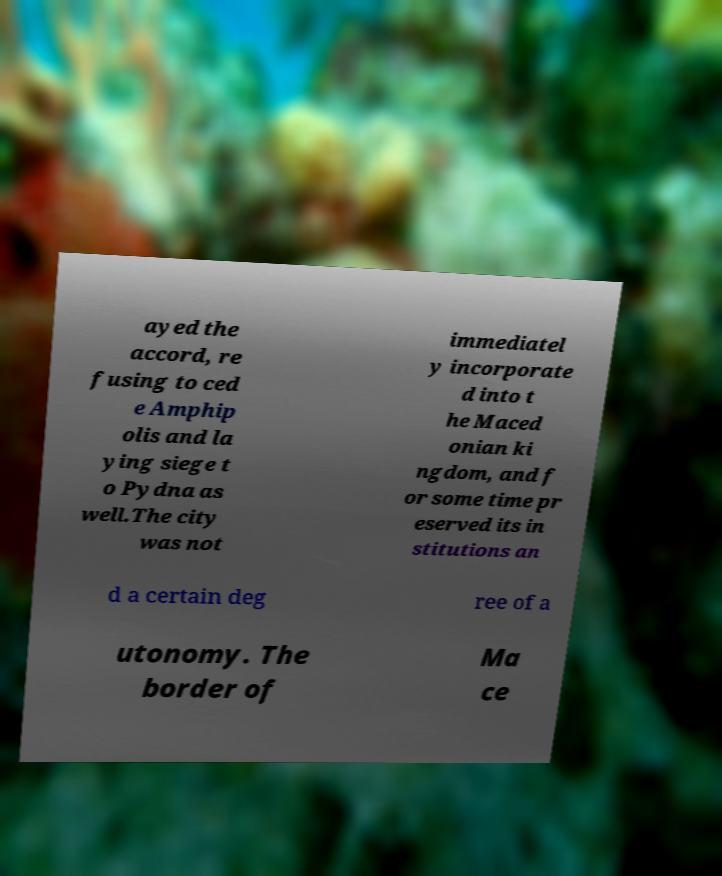Please read and relay the text visible in this image. What does it say? ayed the accord, re fusing to ced e Amphip olis and la ying siege t o Pydna as well.The city was not immediatel y incorporate d into t he Maced onian ki ngdom, and f or some time pr eserved its in stitutions an d a certain deg ree of a utonomy. The border of Ma ce 